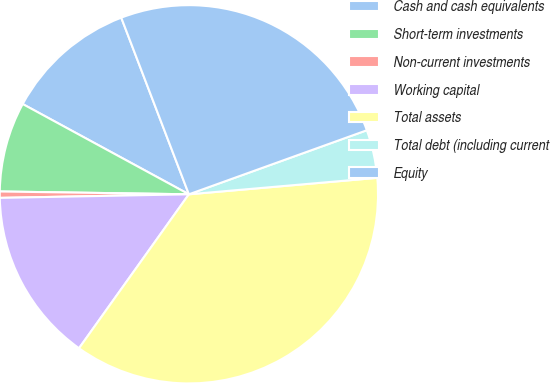Convert chart. <chart><loc_0><loc_0><loc_500><loc_500><pie_chart><fcel>Cash and cash equivalents<fcel>Short-term investments<fcel>Non-current investments<fcel>Working capital<fcel>Total assets<fcel>Total debt (including current<fcel>Equity<nl><fcel>11.26%<fcel>7.68%<fcel>0.54%<fcel>14.83%<fcel>36.25%<fcel>4.11%<fcel>25.32%<nl></chart> 